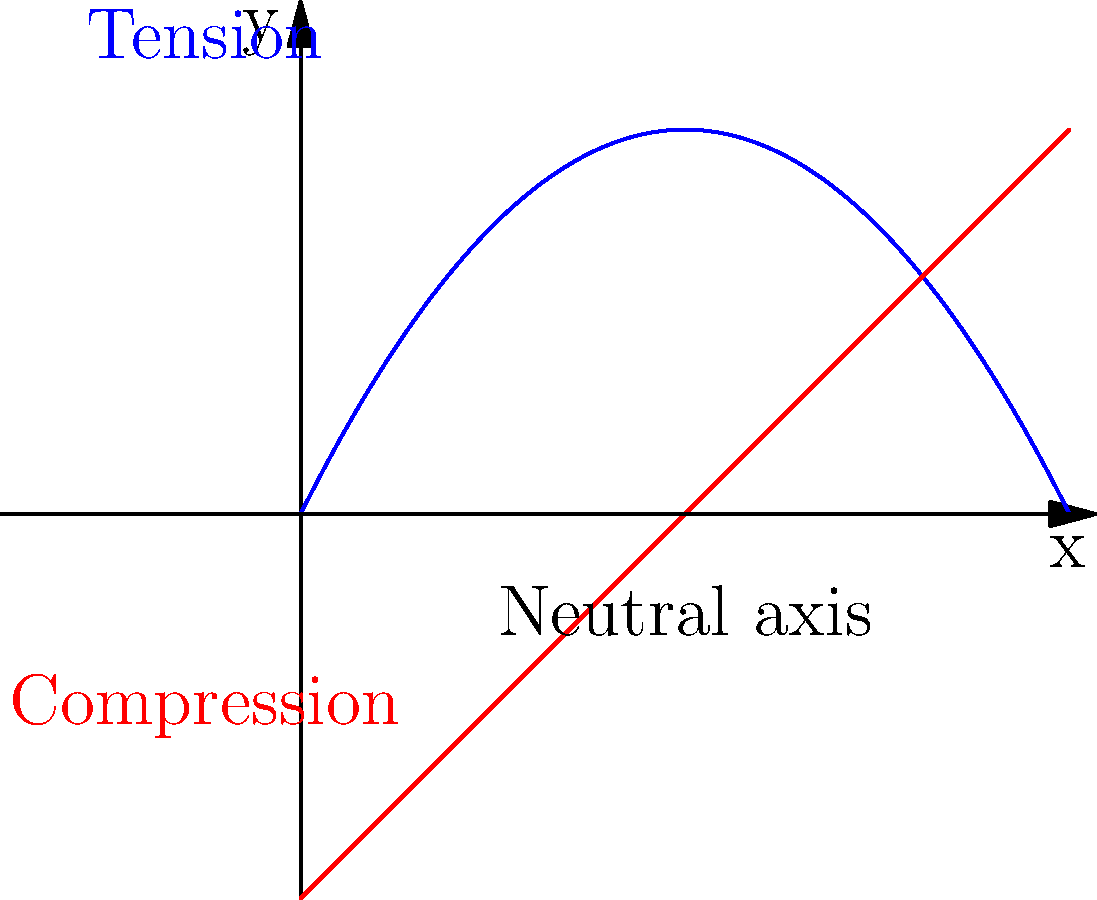In the diagram above, which represents the stress distribution in a beam under bending load, what does the blue curve represent, and why is it shaped this way? To understand the stress distribution in a beam under bending load:

1. The diagram shows a cross-section of a beam experiencing bending.

2. The horizontal dashed line represents the neutral axis, where stress is zero.

3. Above the neutral axis:
   - The blue curve represents tensile stress.
   - It increases in magnitude as we move away from the neutral axis.
   - This is because fibers farther from the neutral axis experience more stretching.

4. The curve's shape:
   - It's parabolic due to the linear variation of strain with distance from the neutral axis.
   - The stress is proportional to strain (according to Hooke's law), resulting in a parabolic stress distribution.

5. Below the neutral axis:
   - The red curve represents compressive stress.
   - It mirrors the tensile stress curve, showing compression increases with distance from the neutral axis.

6. The maximum stress occurs at the outermost fibers, both in tension and compression.

This stress distribution is crucial for calculating the beam's strength and determining its ability to resist bending moments.
Answer: Tensile stress, increasing parabolically with distance from the neutral axis due to linear strain variation and Hooke's law. 